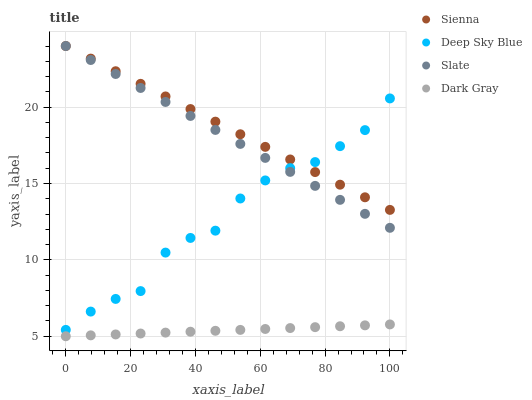Does Dark Gray have the minimum area under the curve?
Answer yes or no. Yes. Does Sienna have the maximum area under the curve?
Answer yes or no. Yes. Does Slate have the minimum area under the curve?
Answer yes or no. No. Does Slate have the maximum area under the curve?
Answer yes or no. No. Is Slate the smoothest?
Answer yes or no. Yes. Is Deep Sky Blue the roughest?
Answer yes or no. Yes. Is Dark Gray the smoothest?
Answer yes or no. No. Is Dark Gray the roughest?
Answer yes or no. No. Does Dark Gray have the lowest value?
Answer yes or no. Yes. Does Slate have the lowest value?
Answer yes or no. No. Does Slate have the highest value?
Answer yes or no. Yes. Does Dark Gray have the highest value?
Answer yes or no. No. Is Dark Gray less than Slate?
Answer yes or no. Yes. Is Sienna greater than Dark Gray?
Answer yes or no. Yes. Does Slate intersect Sienna?
Answer yes or no. Yes. Is Slate less than Sienna?
Answer yes or no. No. Is Slate greater than Sienna?
Answer yes or no. No. Does Dark Gray intersect Slate?
Answer yes or no. No. 